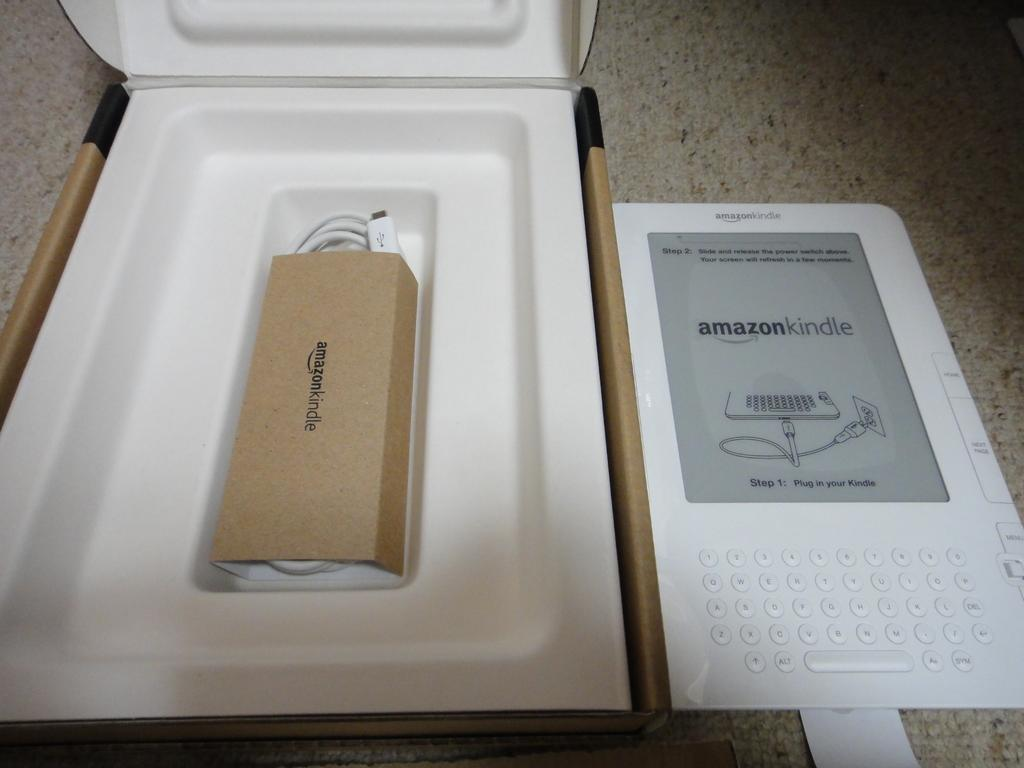<image>
Create a compact narrative representing the image presented. and amazon kindle is still in the original packaging 